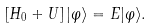Convert formula to latex. <formula><loc_0><loc_0><loc_500><loc_500>\left [ H _ { 0 } + U \right ] | \varphi \rangle = E | \varphi \rangle .</formula> 